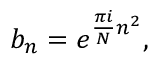Convert formula to latex. <formula><loc_0><loc_0><loc_500><loc_500>b _ { n } = e ^ { { \frac { \pi i } { N } } n ^ { 2 } } ,</formula> 